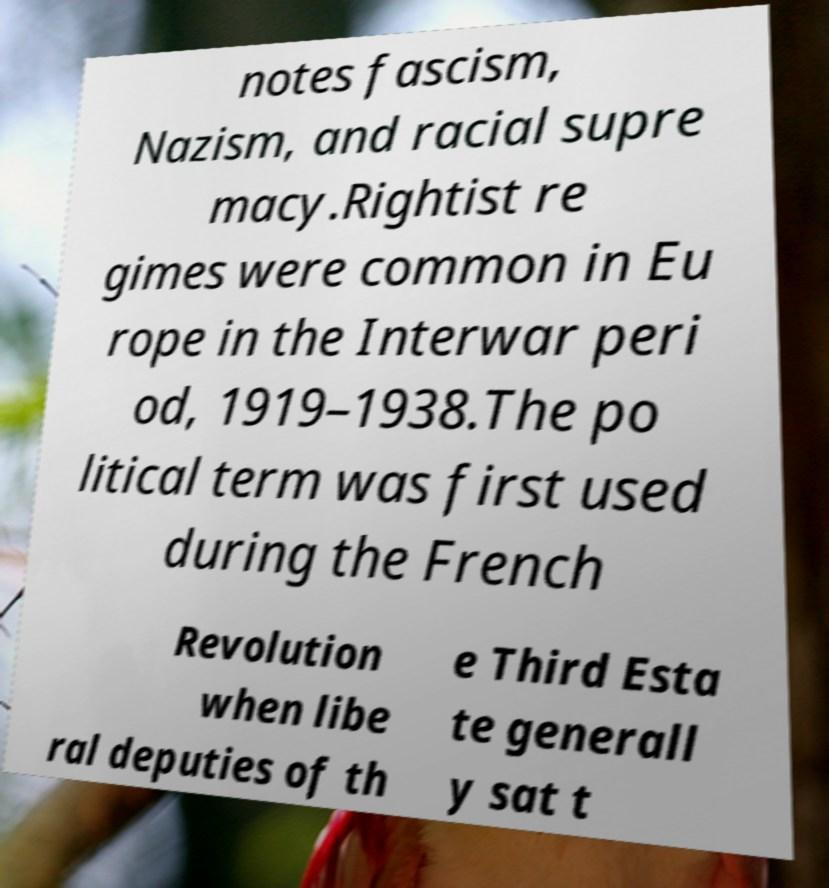Please read and relay the text visible in this image. What does it say? notes fascism, Nazism, and racial supre macy.Rightist re gimes were common in Eu rope in the Interwar peri od, 1919–1938.The po litical term was first used during the French Revolution when libe ral deputies of th e Third Esta te generall y sat t 